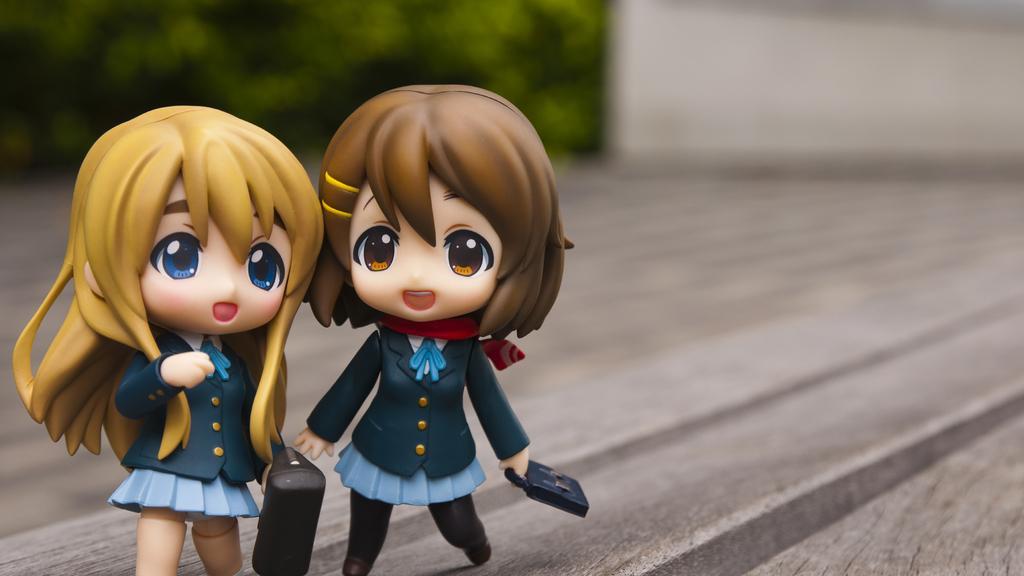Describe this image in one or two sentences. There are two toys on the wooden surface. Background it is blur and green color. 